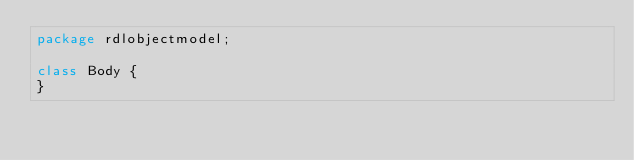<code> <loc_0><loc_0><loc_500><loc_500><_Haxe_>package rdlobjectmodel;

class Body {
}
</code> 